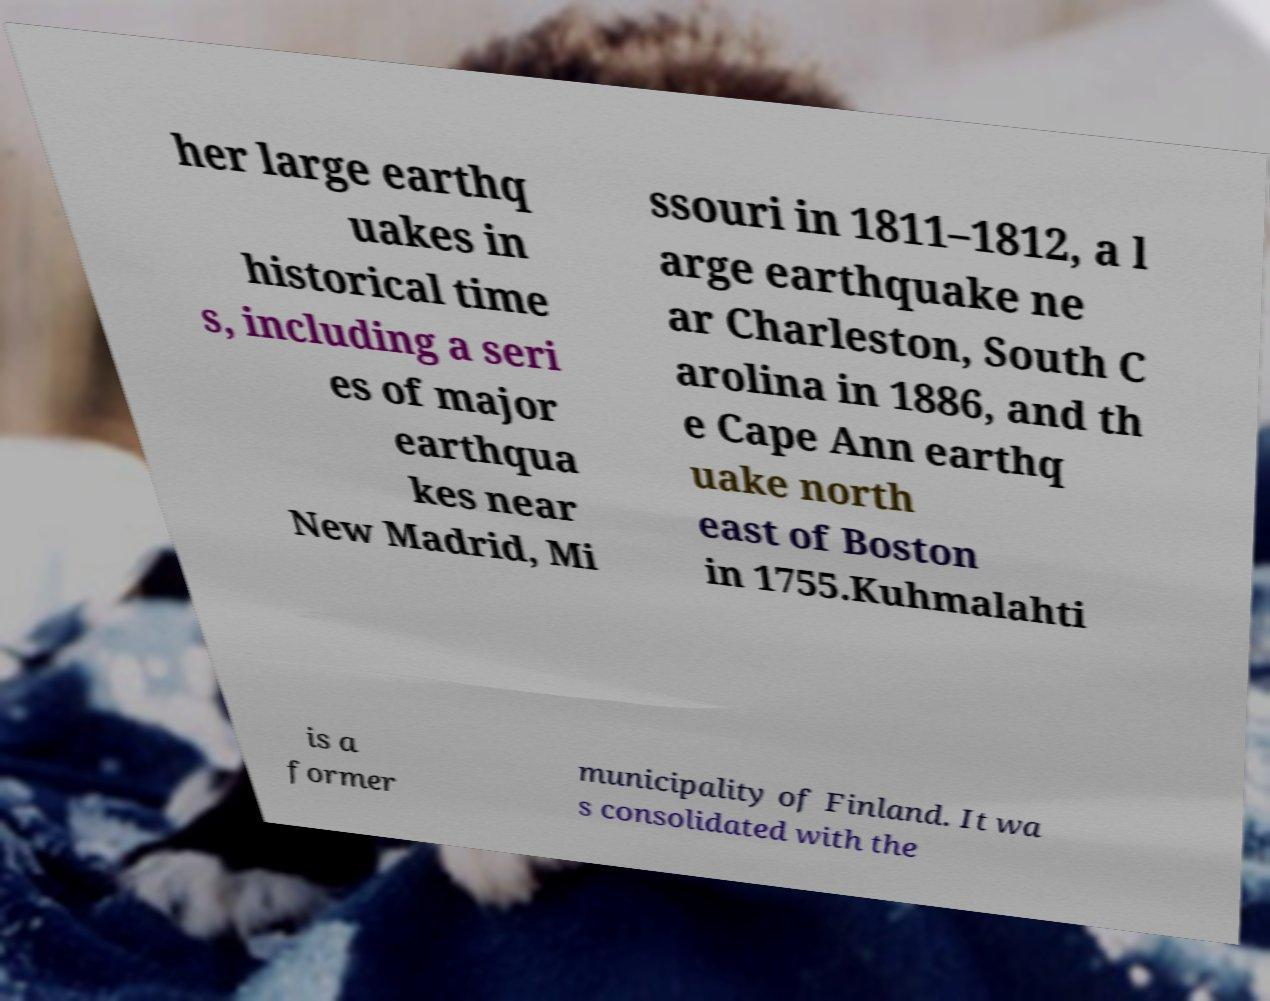For documentation purposes, I need the text within this image transcribed. Could you provide that? her large earthq uakes in historical time s, including a seri es of major earthqua kes near New Madrid, Mi ssouri in 1811–1812, a l arge earthquake ne ar Charleston, South C arolina in 1886, and th e Cape Ann earthq uake north east of Boston in 1755.Kuhmalahti is a former municipality of Finland. It wa s consolidated with the 